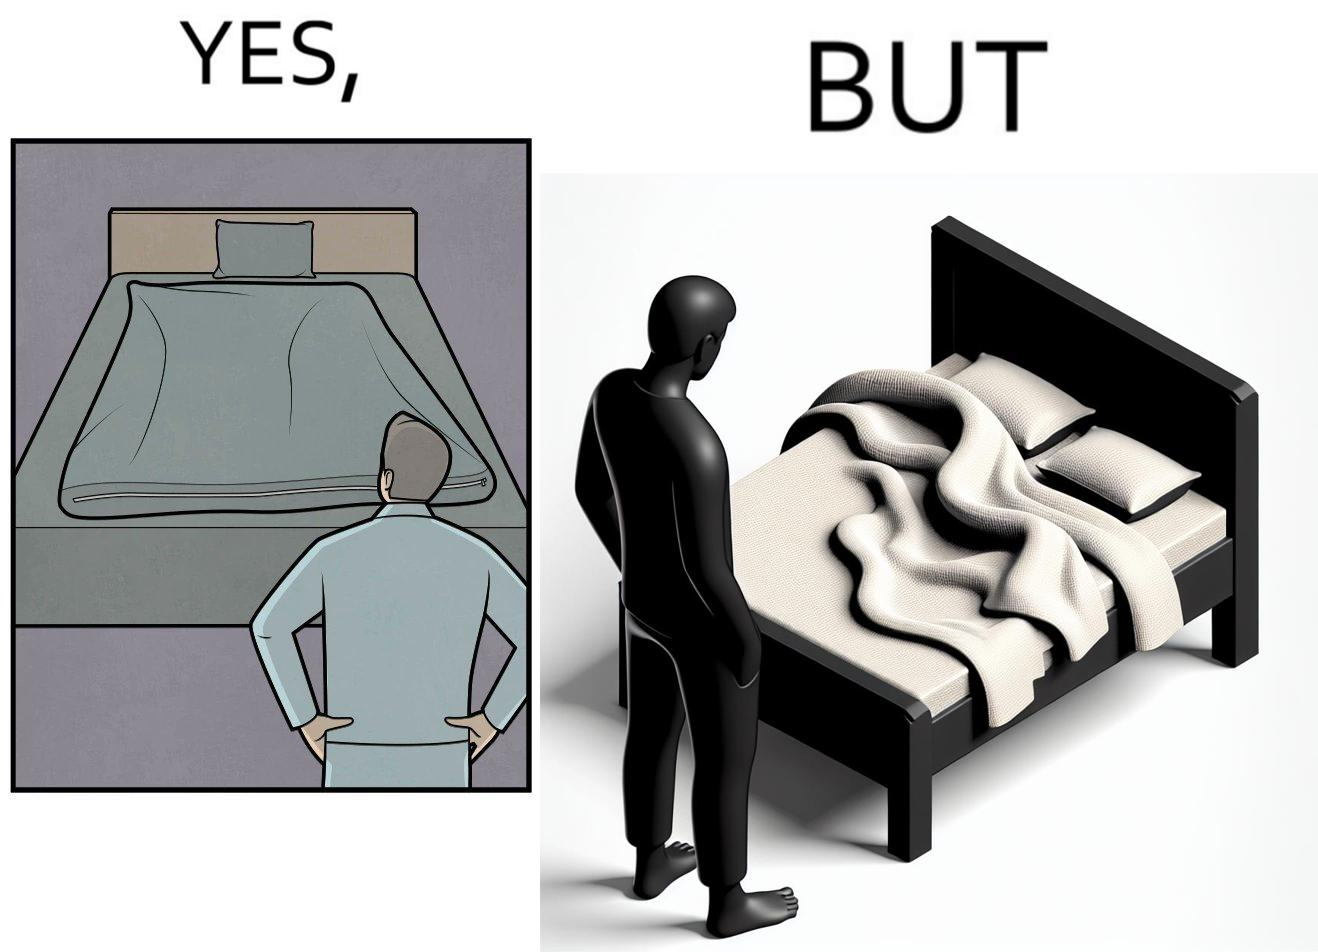Describe the contrast between the left and right parts of this image. In the left part of the image: The image shows a man looking at his bed. His bed seems well made with blanket and pillow properly arranged on the mattress. In the right part of the image: The image shows a man looking at his bed. The image also shows the actual blanket inside its cover on the bed. The blanked is all twisted inside the cover and is not properly set. 